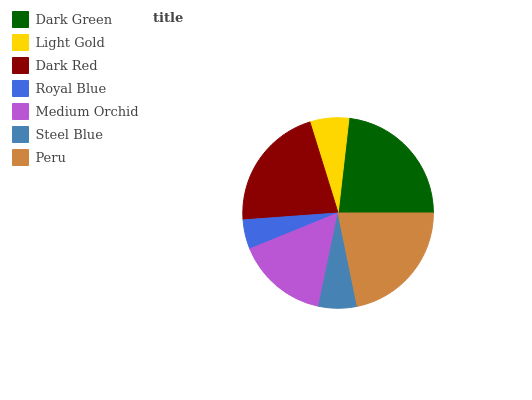Is Royal Blue the minimum?
Answer yes or no. Yes. Is Dark Green the maximum?
Answer yes or no. Yes. Is Light Gold the minimum?
Answer yes or no. No. Is Light Gold the maximum?
Answer yes or no. No. Is Dark Green greater than Light Gold?
Answer yes or no. Yes. Is Light Gold less than Dark Green?
Answer yes or no. Yes. Is Light Gold greater than Dark Green?
Answer yes or no. No. Is Dark Green less than Light Gold?
Answer yes or no. No. Is Medium Orchid the high median?
Answer yes or no. Yes. Is Medium Orchid the low median?
Answer yes or no. Yes. Is Steel Blue the high median?
Answer yes or no. No. Is Steel Blue the low median?
Answer yes or no. No. 